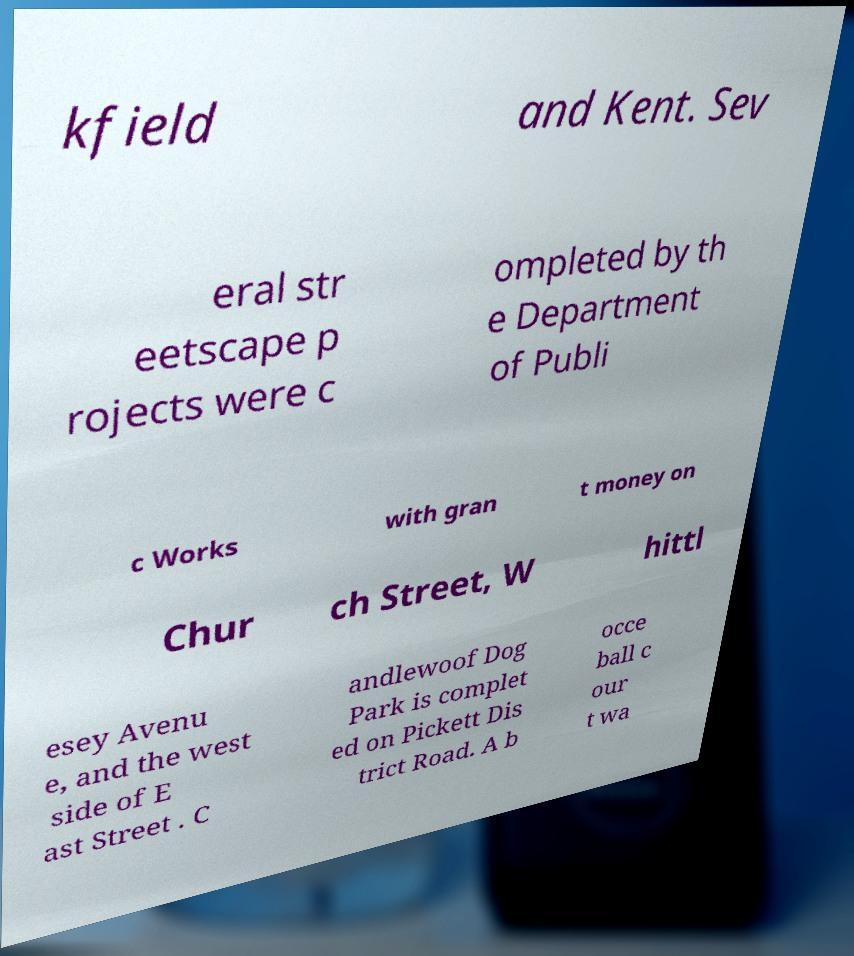For documentation purposes, I need the text within this image transcribed. Could you provide that? kfield and Kent. Sev eral str eetscape p rojects were c ompleted by th e Department of Publi c Works with gran t money on Chur ch Street, W hittl esey Avenu e, and the west side of E ast Street . C andlewoof Dog Park is complet ed on Pickett Dis trict Road. A b occe ball c our t wa 